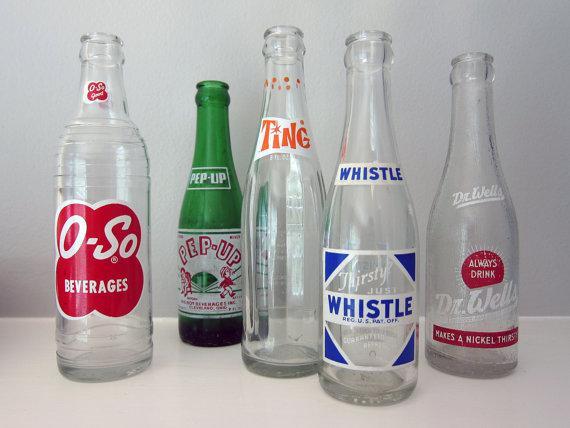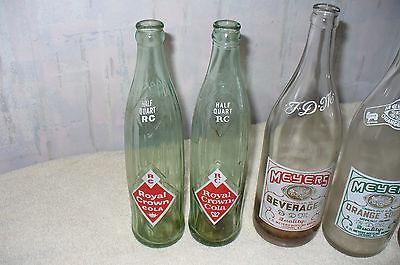The first image is the image on the left, the second image is the image on the right. Evaluate the accuracy of this statement regarding the images: "The left image contains a staggered line of five glass bottles, and the right image contains a straighter row of four bottles.". Is it true? Answer yes or no. Yes. The first image is the image on the left, the second image is the image on the right. Examine the images to the left and right. Is the description "There are four bottles in one image and five in the other." accurate? Answer yes or no. Yes. 